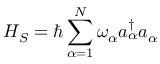<formula> <loc_0><loc_0><loc_500><loc_500>H _ { S } = \hbar { \sum } _ { \alpha = 1 } ^ { N } \omega _ { \alpha } a _ { \alpha } ^ { \dagger } a _ { \alpha }</formula> 